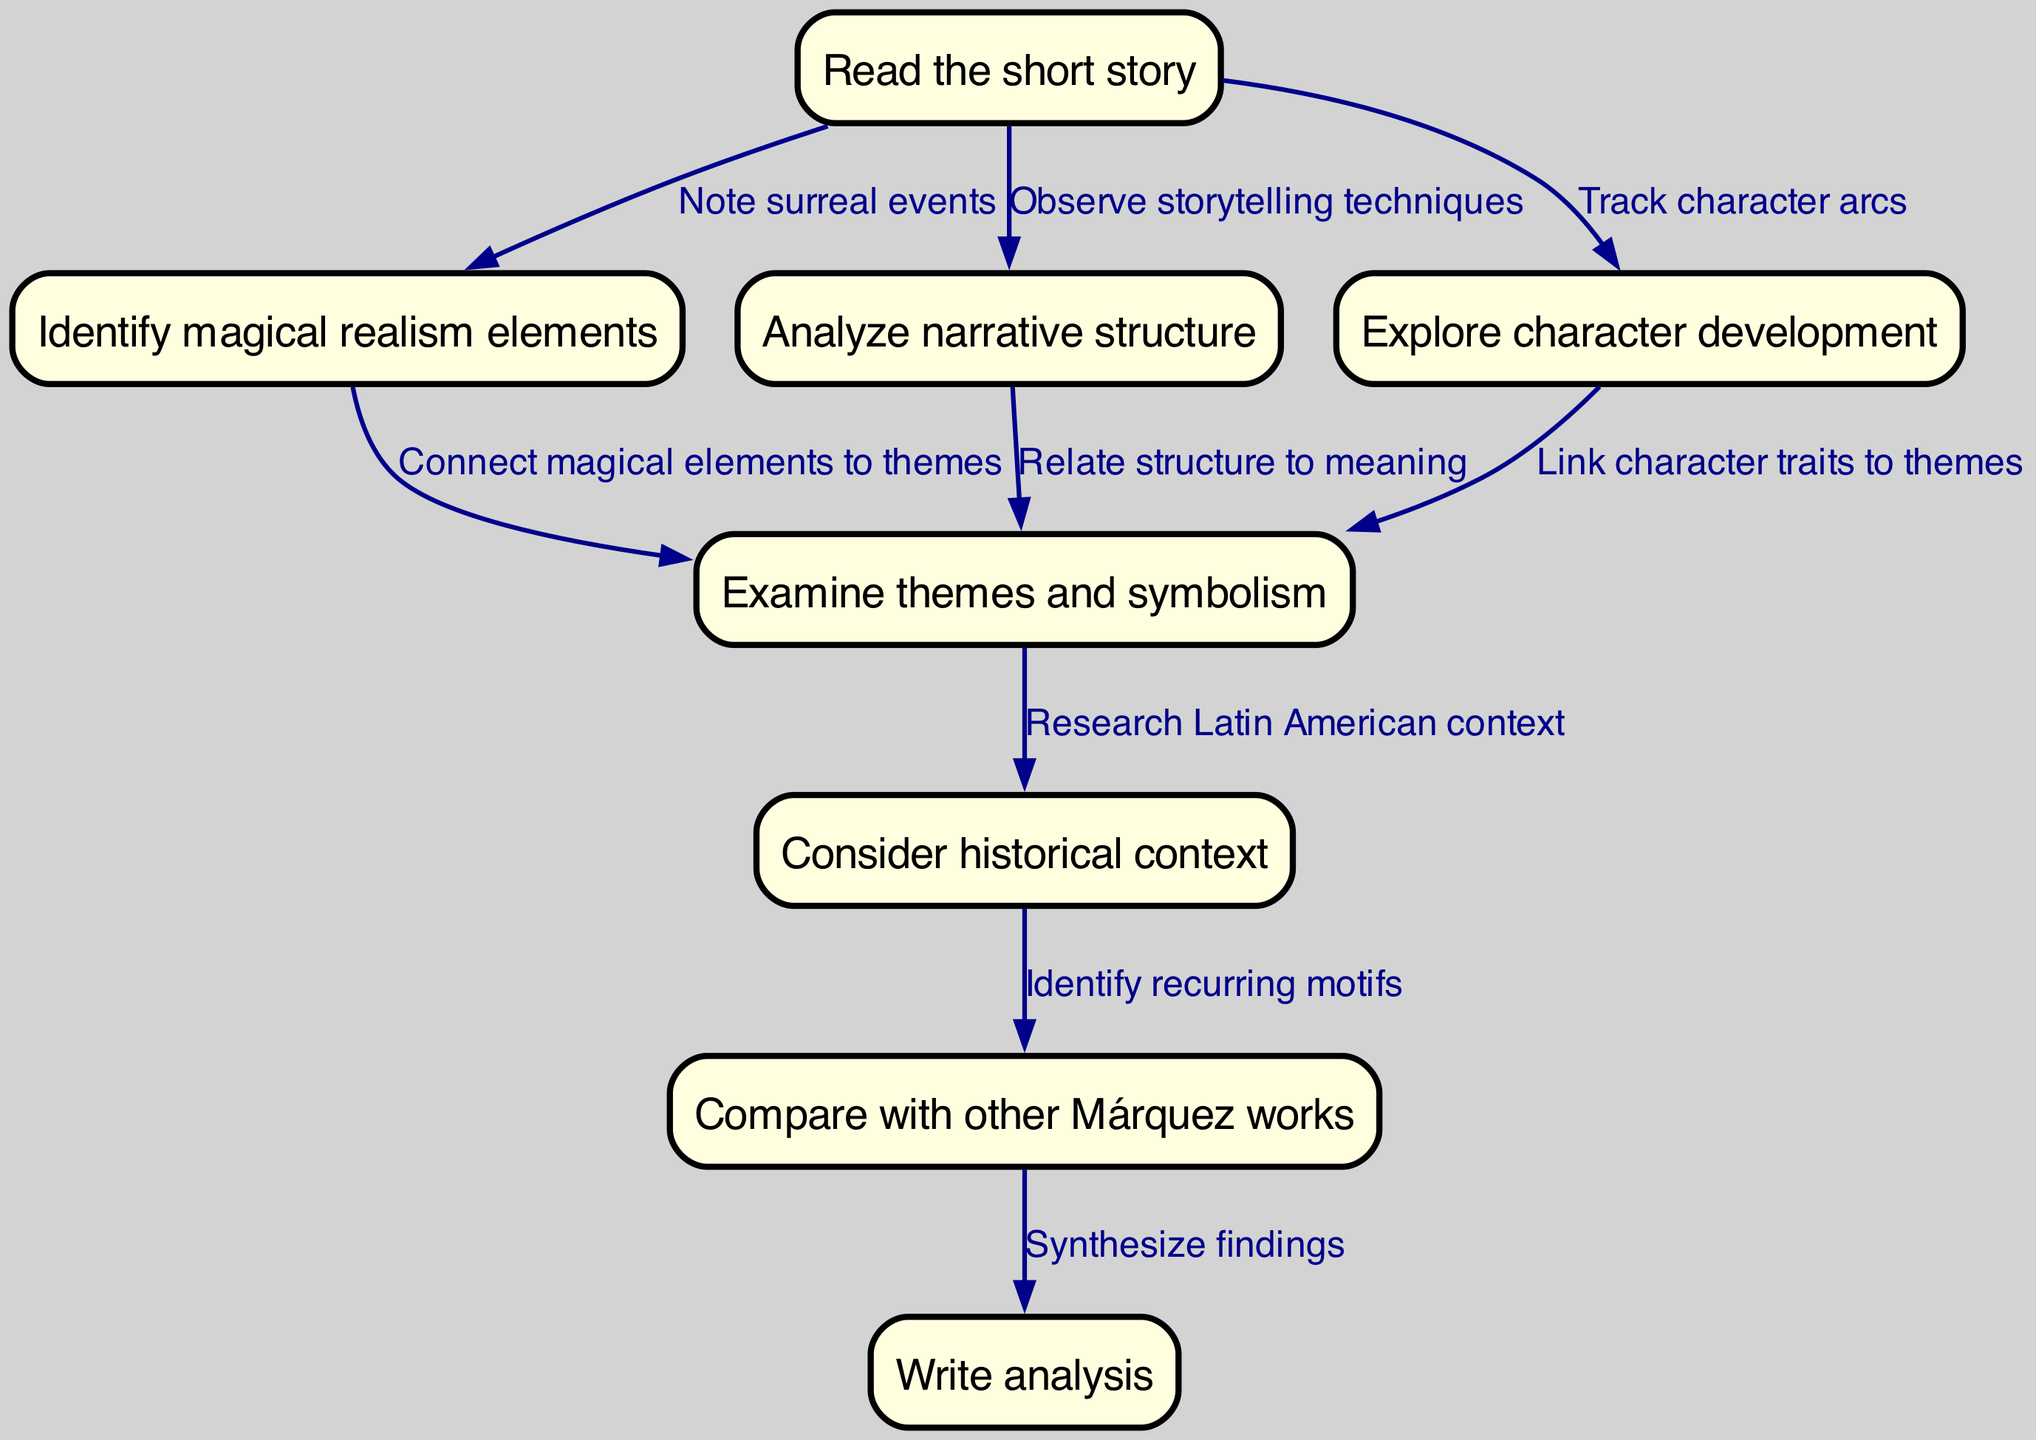What is the first step in the literary analysis process? The first step listed in the diagram is "Read the short story." It is indicated as the starting node from which all other steps emanate.
Answer: Read the short story How many nodes are present in the diagram? By counting the nodes depicted in the diagram, there are a total of eight nodes representing different steps in the literary analysis process.
Answer: Eight What connects the node "Identify magical realism elements" to "Examine themes and symbolism"? The connection between these two nodes is made by the edge labeled "Connect magical elements to themes," which indicates a relationship of analysis between magical realism elements and the themes present in the stories.
Answer: Connect magical elements to themes What is the final step in the flowchart? The final step outlined in the flowchart is "Write analysis," which is reached after synthesizing findings from previous analyses.
Answer: Write analysis Which node is the direct predecessor of "Write analysis"? The direct predecessor of the "Write analysis" node is "Compare with other Márquez works," indicating that one must compare previous works before formulating the analysis in writing.
Answer: Compare with other Márquez works How does "Analyze narrative structure" relate to "Examine themes and symbolism"? The relationship is established through the edge that states "Relate structure to meaning." This indicates that understanding the narrative structure is crucial to discovering deeper themes and symbolic meanings within the story.
Answer: Relate structure to meaning How many edges connect to the "Examine themes and symbolism" node? The "Examine themes and symbolism" node is directly connected to three edges coming from the nodes "Identify magical realism elements," "Analyze narrative structure," and "Explore character development." This indicates a multifaceted relationship with other aspects of the short story analysis.
Answer: Three Which two nodes relate in exploring character traits and themes? The two nodes that relate in this context are "Explore character development" and "Examine themes and symbolism." The edge connecting them is labeled "Link character traits to themes," revealing that character development offers insights into the thematic content of the stories.
Answer: Link character traits to themes 